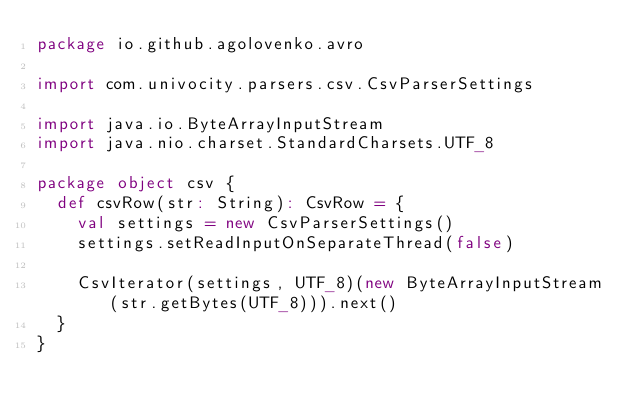Convert code to text. <code><loc_0><loc_0><loc_500><loc_500><_Scala_>package io.github.agolovenko.avro

import com.univocity.parsers.csv.CsvParserSettings

import java.io.ByteArrayInputStream
import java.nio.charset.StandardCharsets.UTF_8

package object csv {
  def csvRow(str: String): CsvRow = {
    val settings = new CsvParserSettings()
    settings.setReadInputOnSeparateThread(false)

    CsvIterator(settings, UTF_8)(new ByteArrayInputStream(str.getBytes(UTF_8))).next()
  }
}
</code> 